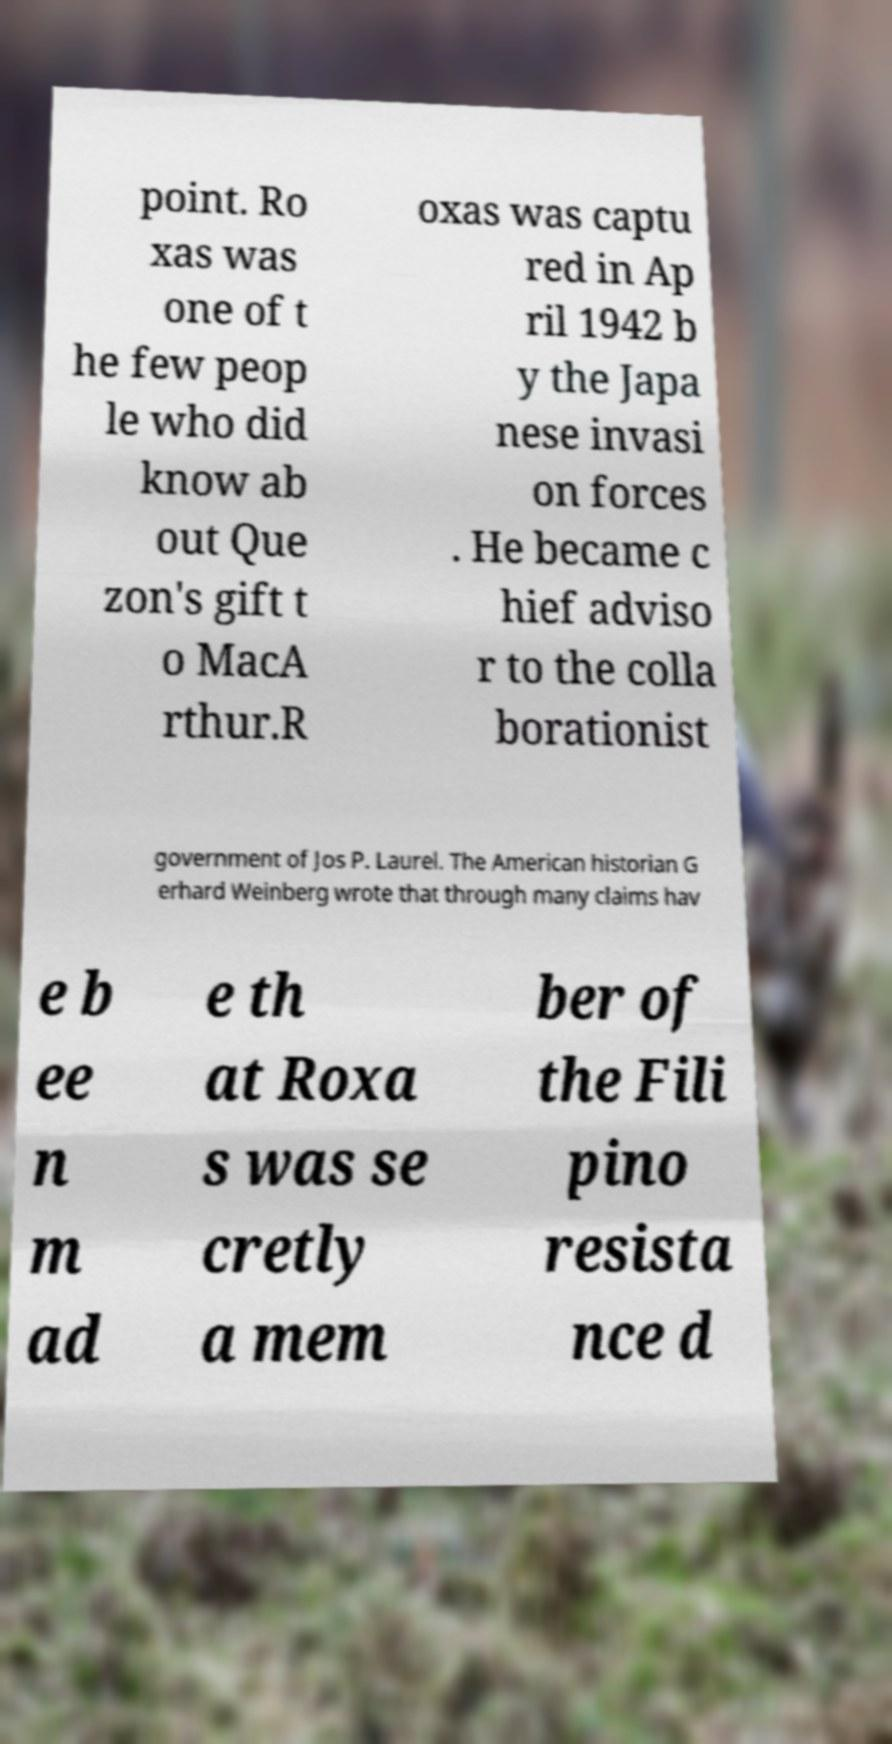Please identify and transcribe the text found in this image. point. Ro xas was one of t he few peop le who did know ab out Que zon's gift t o MacA rthur.R oxas was captu red in Ap ril 1942 b y the Japa nese invasi on forces . He became c hief adviso r to the colla borationist government of Jos P. Laurel. The American historian G erhard Weinberg wrote that through many claims hav e b ee n m ad e th at Roxa s was se cretly a mem ber of the Fili pino resista nce d 